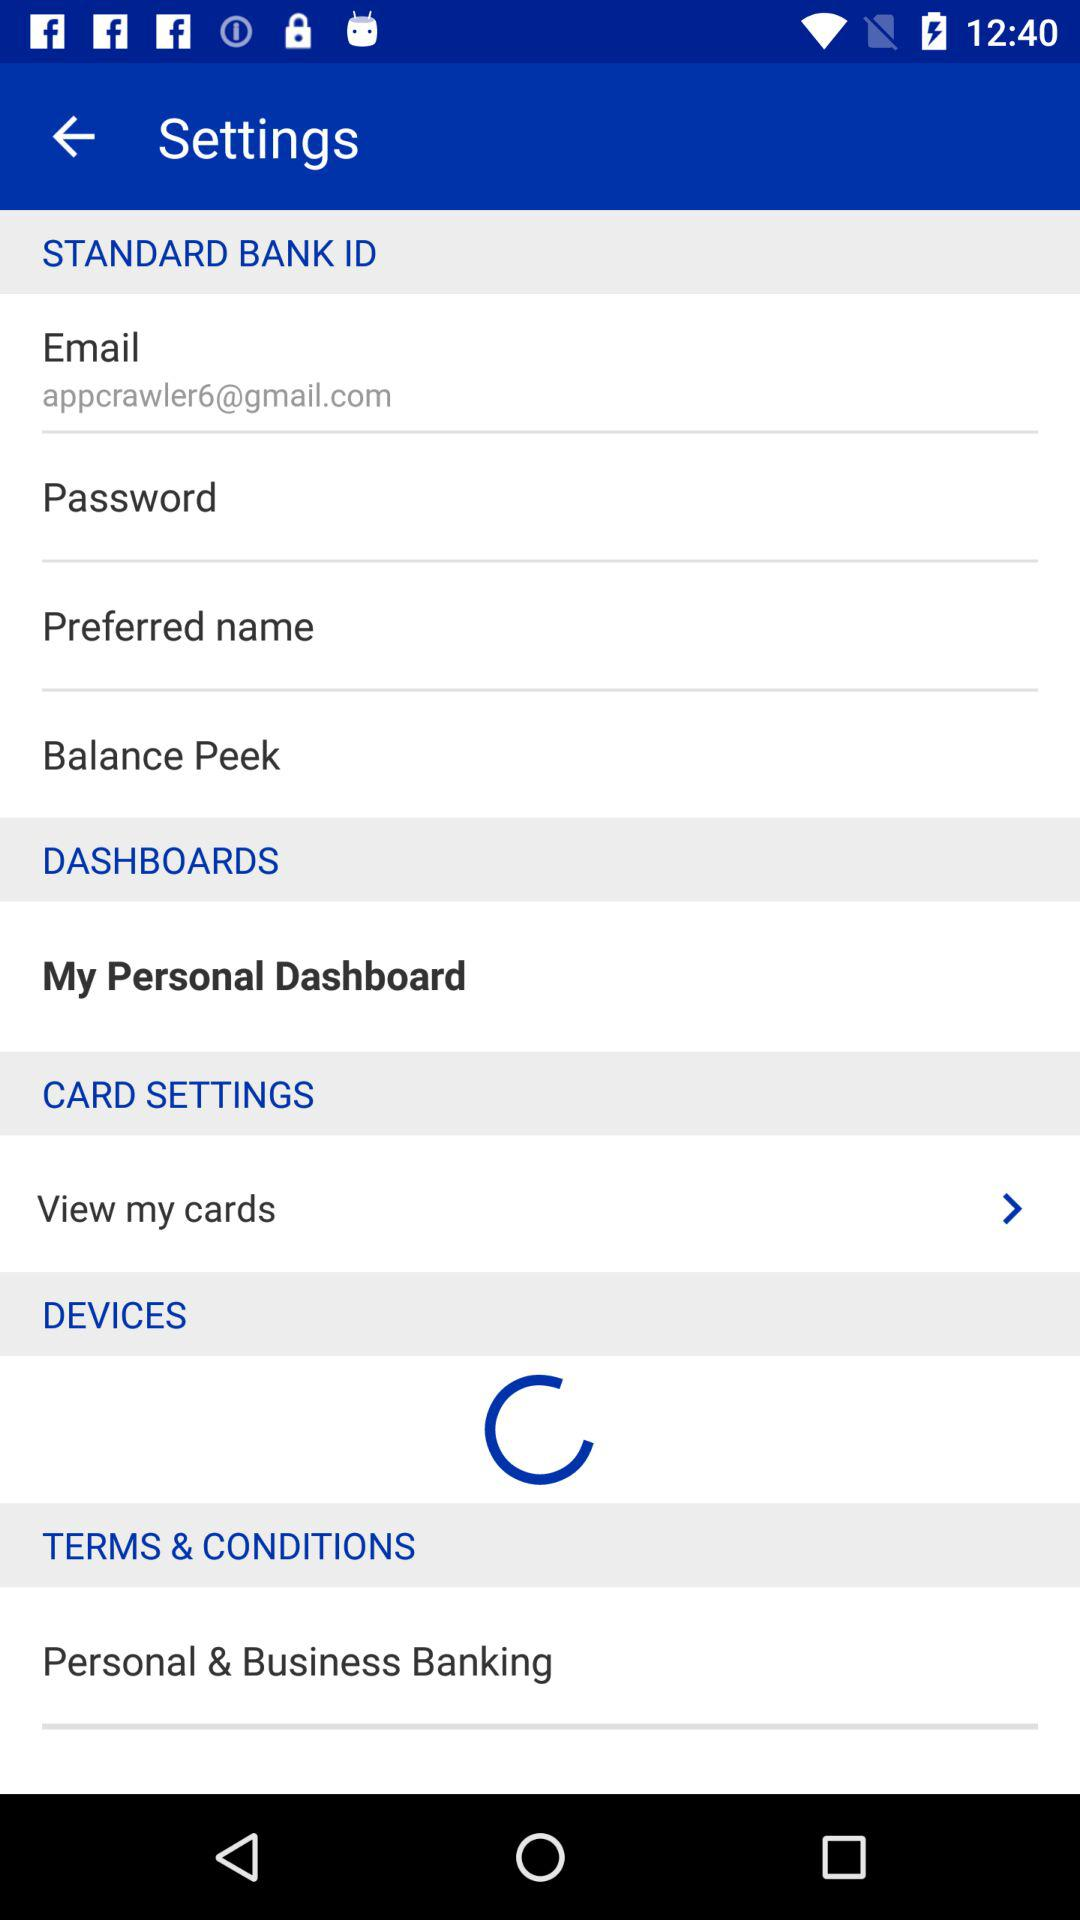What's the name of the Gmail address used for "STANDARD BANK ID"? The name of the Gmail address used for "STANDARD BANK ID" is appcrawler6@gmail.com. 